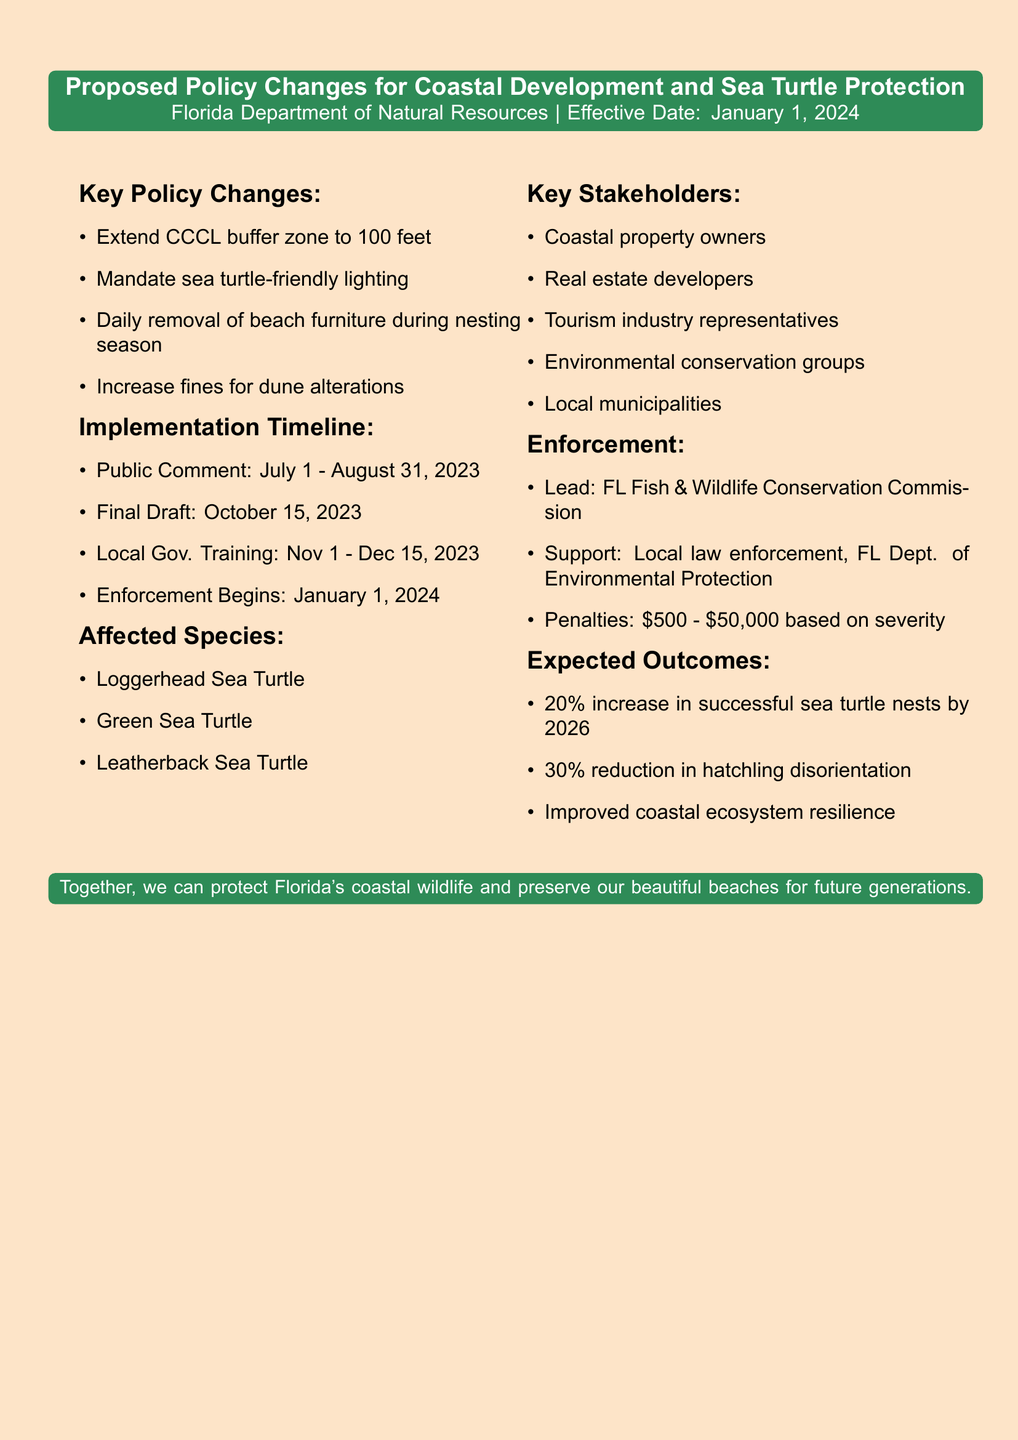What is the effective date of the proposed policy changes? The effective date is specified in the document as January 1, 2024.
Answer: January 1, 2024 What is the new buffer zone distance for the Coastal Construction Control Line? The document indicates that the buffer zone will be extended to 100 feet inland from the mean high water line.
Answer: 100 feet Which agency is responsible for leading the enforcement of the proposed policy changes? The document states that the Florida Fish and Wildlife Conservation Commission will lead the enforcement.
Answer: Florida Fish and Wildlife Conservation Commission What is the expected percentage increase in successful sea turtle nests by 2026? The document expects a 20% increase in successful sea turtle nests by the year 2026.
Answer: 20% What is the period for the public comment phase? The document outlines that the public comment period will take place from July 1 to August 31, 2023.
Answer: July 1 - August 31, 2023 What are the key stakeholders involved in this policy? The document lists several key stakeholders, including coastal property owners, real estate developers, and environmental conservation groups.
Answer: Coastal property owners, real estate developers, tourism industry representatives, environmental conservation groups, local municipalities How much will fines for unauthorized dune alterations increase? The document specifies that fines for unauthorized dune alterations will increase from $10,000 to $25,000 per incident.
Answer: $25,000 What is the reduction expected in hatchling disorientation incidents? According to the document, a 30% reduction in hatchling disorientation incidents is anticipated.
Answer: 30% 